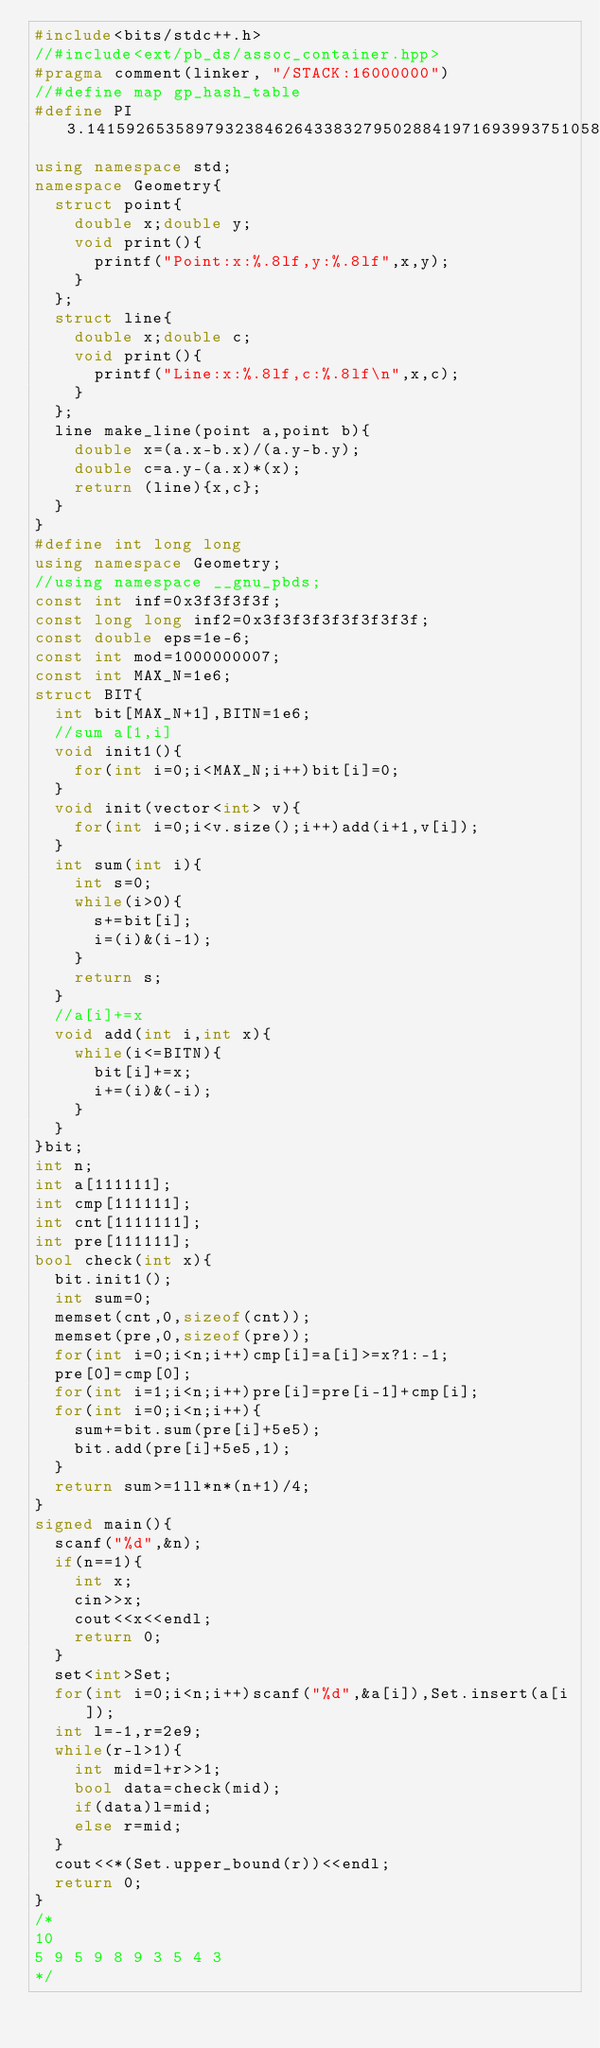Convert code to text. <code><loc_0><loc_0><loc_500><loc_500><_C++_>#include<bits/stdc++.h>
//#include<ext/pb_ds/assoc_container.hpp>
#pragma comment(linker, "/STACK:16000000")
//#define map gp_hash_table
#define PI 3.1415926535897932384626433832795028841971693993751058209749445923078164062862089986280348253421170679
using namespace std;
namespace Geometry{
	struct point{
		double x;double y;
		void print(){
			printf("Point:x:%.8lf,y:%.8lf",x,y);
		}
	};
	struct line{
		double x;double c;
		void print(){
			printf("Line:x:%.8lf,c:%.8lf\n",x,c);
		}
	};
	line make_line(point a,point b){
		double x=(a.x-b.x)/(a.y-b.y);
		double c=a.y-(a.x)*(x);
		return (line){x,c};
	}
}
#define int long long
using namespace Geometry;
//using namespace __gnu_pbds;
const int inf=0x3f3f3f3f;
const long long inf2=0x3f3f3f3f3f3f3f3f;
const double eps=1e-6;
const int mod=1000000007;
const int MAX_N=1e6;
struct BIT{
	int bit[MAX_N+1],BITN=1e6;
	//sum a[1,i]
	void init1(){
		for(int i=0;i<MAX_N;i++)bit[i]=0;
	}
	void init(vector<int> v){
		for(int i=0;i<v.size();i++)add(i+1,v[i]);
	}
	int sum(int i){
		int s=0;
		while(i>0){
			s+=bit[i];
			i=(i)&(i-1);
		}
		return s;
	}
	//a[i]+=x
	void add(int i,int x){
		while(i<=BITN){
			bit[i]+=x;
			i+=(i)&(-i);
		}
	}
}bit;
int n;
int a[111111];
int cmp[111111];
int cnt[1111111];
int pre[111111];
bool check(int x){
	bit.init1();
	int sum=0;
	memset(cnt,0,sizeof(cnt));
	memset(pre,0,sizeof(pre));
	for(int i=0;i<n;i++)cmp[i]=a[i]>=x?1:-1;
	pre[0]=cmp[0];
	for(int i=1;i<n;i++)pre[i]=pre[i-1]+cmp[i];
	for(int i=0;i<n;i++){
		sum+=bit.sum(pre[i]+5e5);
		bit.add(pre[i]+5e5,1);
	}
	return sum>=1ll*n*(n+1)/4;
}
signed main(){
	scanf("%d",&n);
	if(n==1){
		int x;
		cin>>x;
		cout<<x<<endl;
		return 0;
	}
	set<int>Set;
	for(int i=0;i<n;i++)scanf("%d",&a[i]),Set.insert(a[i]);
	int l=-1,r=2e9;
	while(r-l>1){
		int mid=l+r>>1;
		bool data=check(mid);
		if(data)l=mid;
		else r=mid;
	}
	cout<<*(Set.upper_bound(r))<<endl;
	return 0;
}
/*
10
5 9 5 9 8 9 3 5 4 3
*/</code> 